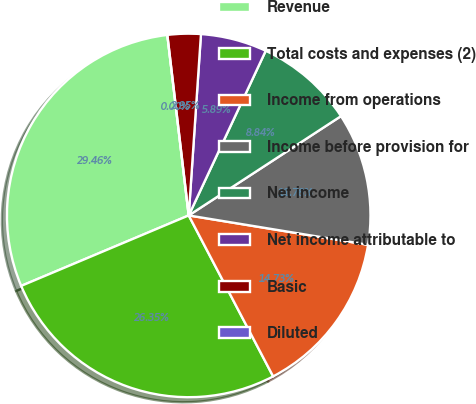<chart> <loc_0><loc_0><loc_500><loc_500><pie_chart><fcel>Revenue<fcel>Total costs and expenses (2)<fcel>Income from operations<fcel>Income before provision for<fcel>Net income<fcel>Net income attributable to<fcel>Basic<fcel>Diluted<nl><fcel>29.46%<fcel>26.35%<fcel>14.73%<fcel>11.78%<fcel>8.84%<fcel>5.89%<fcel>2.95%<fcel>0.0%<nl></chart> 